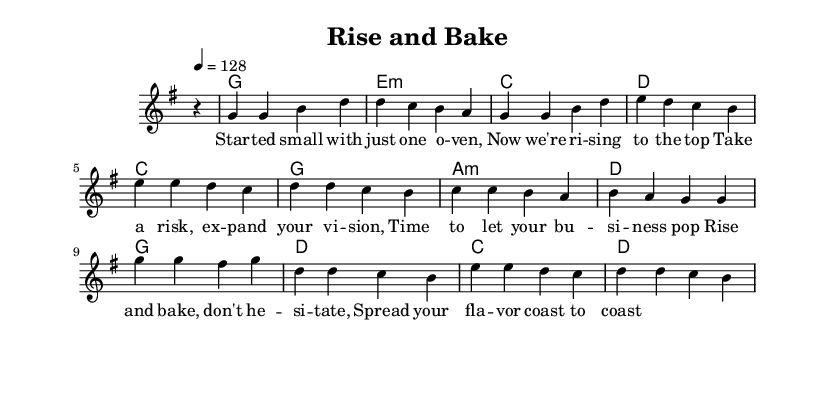What is the key signature of this music? The key signature is G major, which has one sharp, F sharp.
Answer: G major What is the time signature of this piece? The time signature is 4/4, meaning there are four beats in each measure.
Answer: 4/4 What is the tempo marking for the piece? The tempo marking indicates a speed of 128 beats per minute.
Answer: 128 How many measures are in the melody section? The melody section consists of 16 measures in total. To count, we look at the number of bars present in the melody line.
Answer: 16 What are the primary chords used in the harmonies? The primary chords are G, E minor, C, D, and A minor based on the chord names listed.
Answer: G, E minor, C, D, A minor What is the overall theme of the lyrics? The overall theme revolves around growth and taking risks in business, particularly in baking. This is inferred from phrases like "rise and bake" and "spread your flavor."
Answer: Growth and risk-taking 